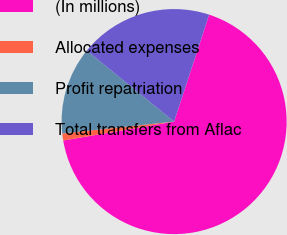Convert chart. <chart><loc_0><loc_0><loc_500><loc_500><pie_chart><fcel>(In millions)<fcel>Allocated expenses<fcel>Profit repatriation<fcel>Total transfers from Aflac<nl><fcel>67.27%<fcel>1.01%<fcel>12.55%<fcel>19.17%<nl></chart> 